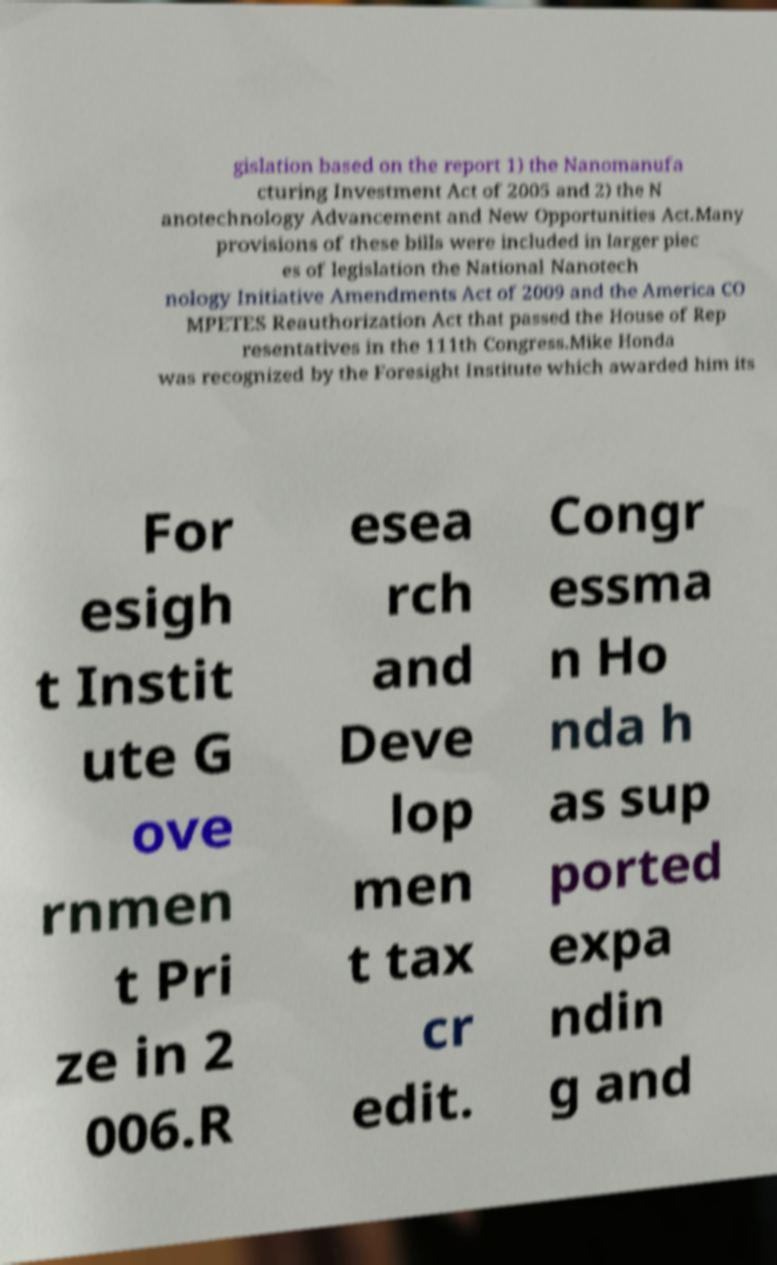Please read and relay the text visible in this image. What does it say? gislation based on the report 1) the Nanomanufa cturing Investment Act of 2005 and 2) the N anotechnology Advancement and New Opportunities Act.Many provisions of these bills were included in larger piec es of legislation the National Nanotech nology Initiative Amendments Act of 2009 and the America CO MPETES Reauthorization Act that passed the House of Rep resentatives in the 111th Congress.Mike Honda was recognized by the Foresight Institute which awarded him its For esigh t Instit ute G ove rnmen t Pri ze in 2 006.R esea rch and Deve lop men t tax cr edit. Congr essma n Ho nda h as sup ported expa ndin g and 